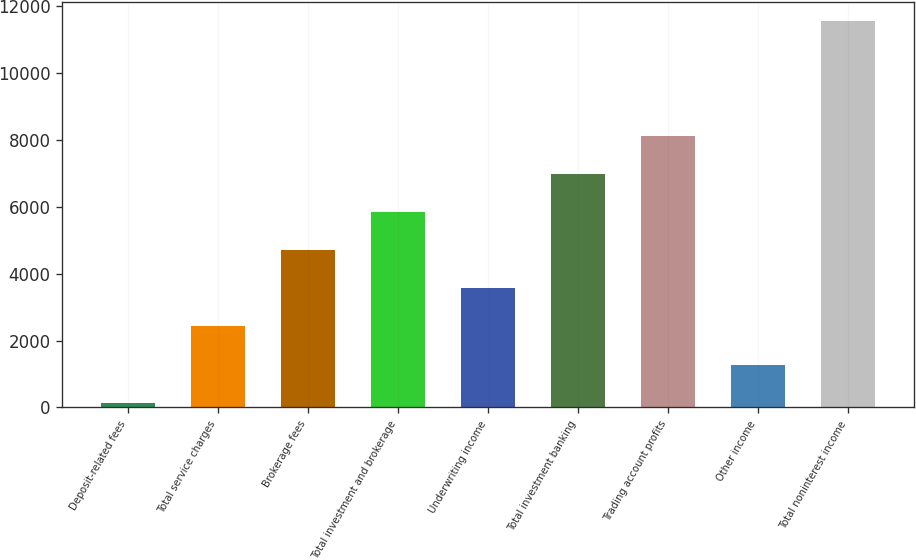<chart> <loc_0><loc_0><loc_500><loc_500><bar_chart><fcel>Deposit-related fees<fcel>Total service charges<fcel>Brokerage fees<fcel>Total investment and brokerage<fcel>Underwriting income<fcel>Total investment banking<fcel>Trading account profits<fcel>Other income<fcel>Total noninterest income<nl><fcel>143<fcel>2421<fcel>4699<fcel>5838<fcel>3560<fcel>6977<fcel>8116<fcel>1282<fcel>11533<nl></chart> 